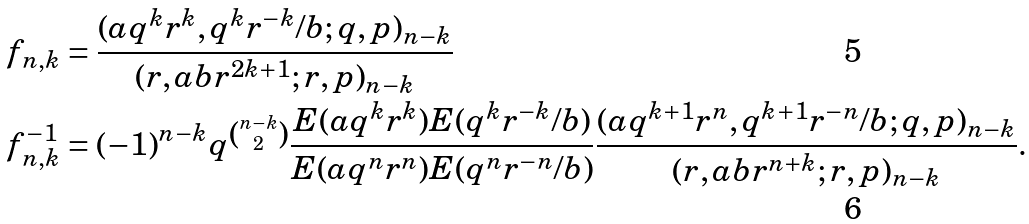<formula> <loc_0><loc_0><loc_500><loc_500>f _ { n , k } & = \frac { ( a q ^ { k } r ^ { k } , q ^ { k } r ^ { - k } / b ; q , p ) _ { n - k } } { ( r , a b r ^ { 2 k + 1 } ; r , p ) _ { n - k } } \\ f ^ { - 1 } _ { n , k } & = ( - 1 ) ^ { n - k } q ^ { \binom { n - k } { 2 } } \frac { E ( a q ^ { k } r ^ { k } ) E ( q ^ { k } r ^ { - k } / b ) } { E ( a q ^ { n } r ^ { n } ) E ( q ^ { n } r ^ { - n } / b ) } \frac { ( a q ^ { k + 1 } r ^ { n } , q ^ { k + 1 } r ^ { - n } / b ; q , p ) _ { n - k } } { ( r , a b r ^ { n + k } ; r , p ) _ { n - k } } .</formula> 